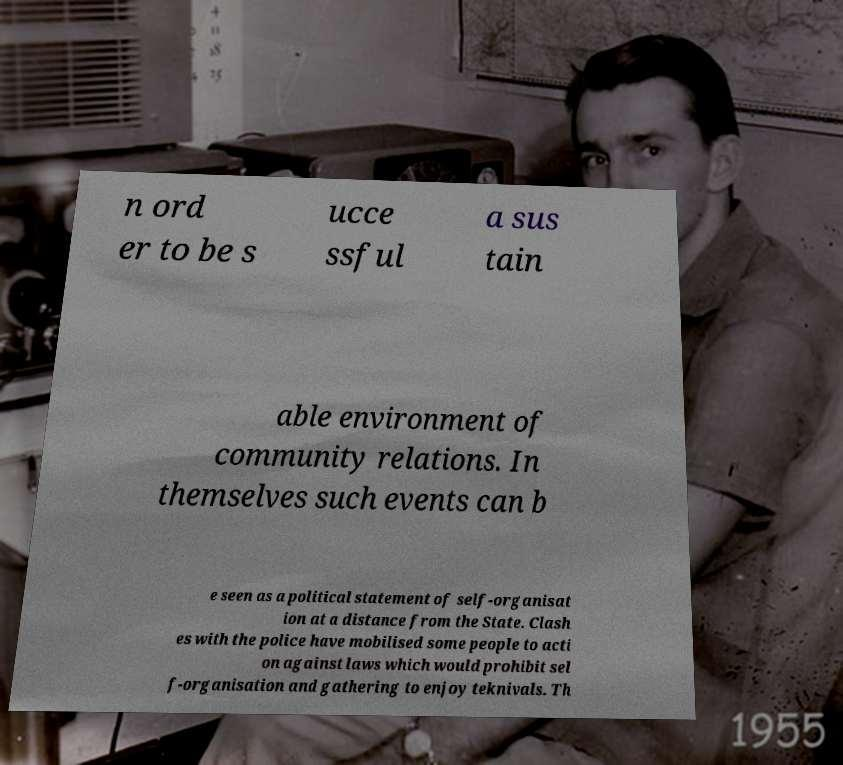Can you read and provide the text displayed in the image?This photo seems to have some interesting text. Can you extract and type it out for me? n ord er to be s ucce ssful a sus tain able environment of community relations. In themselves such events can b e seen as a political statement of self-organisat ion at a distance from the State. Clash es with the police have mobilised some people to acti on against laws which would prohibit sel f-organisation and gathering to enjoy teknivals. Th 